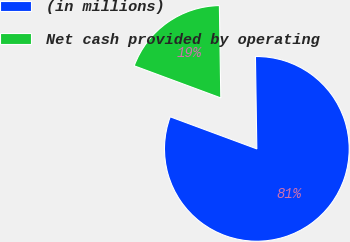<chart> <loc_0><loc_0><loc_500><loc_500><pie_chart><fcel>(in millions)<fcel>Net cash provided by operating<nl><fcel>80.89%<fcel>19.11%<nl></chart> 